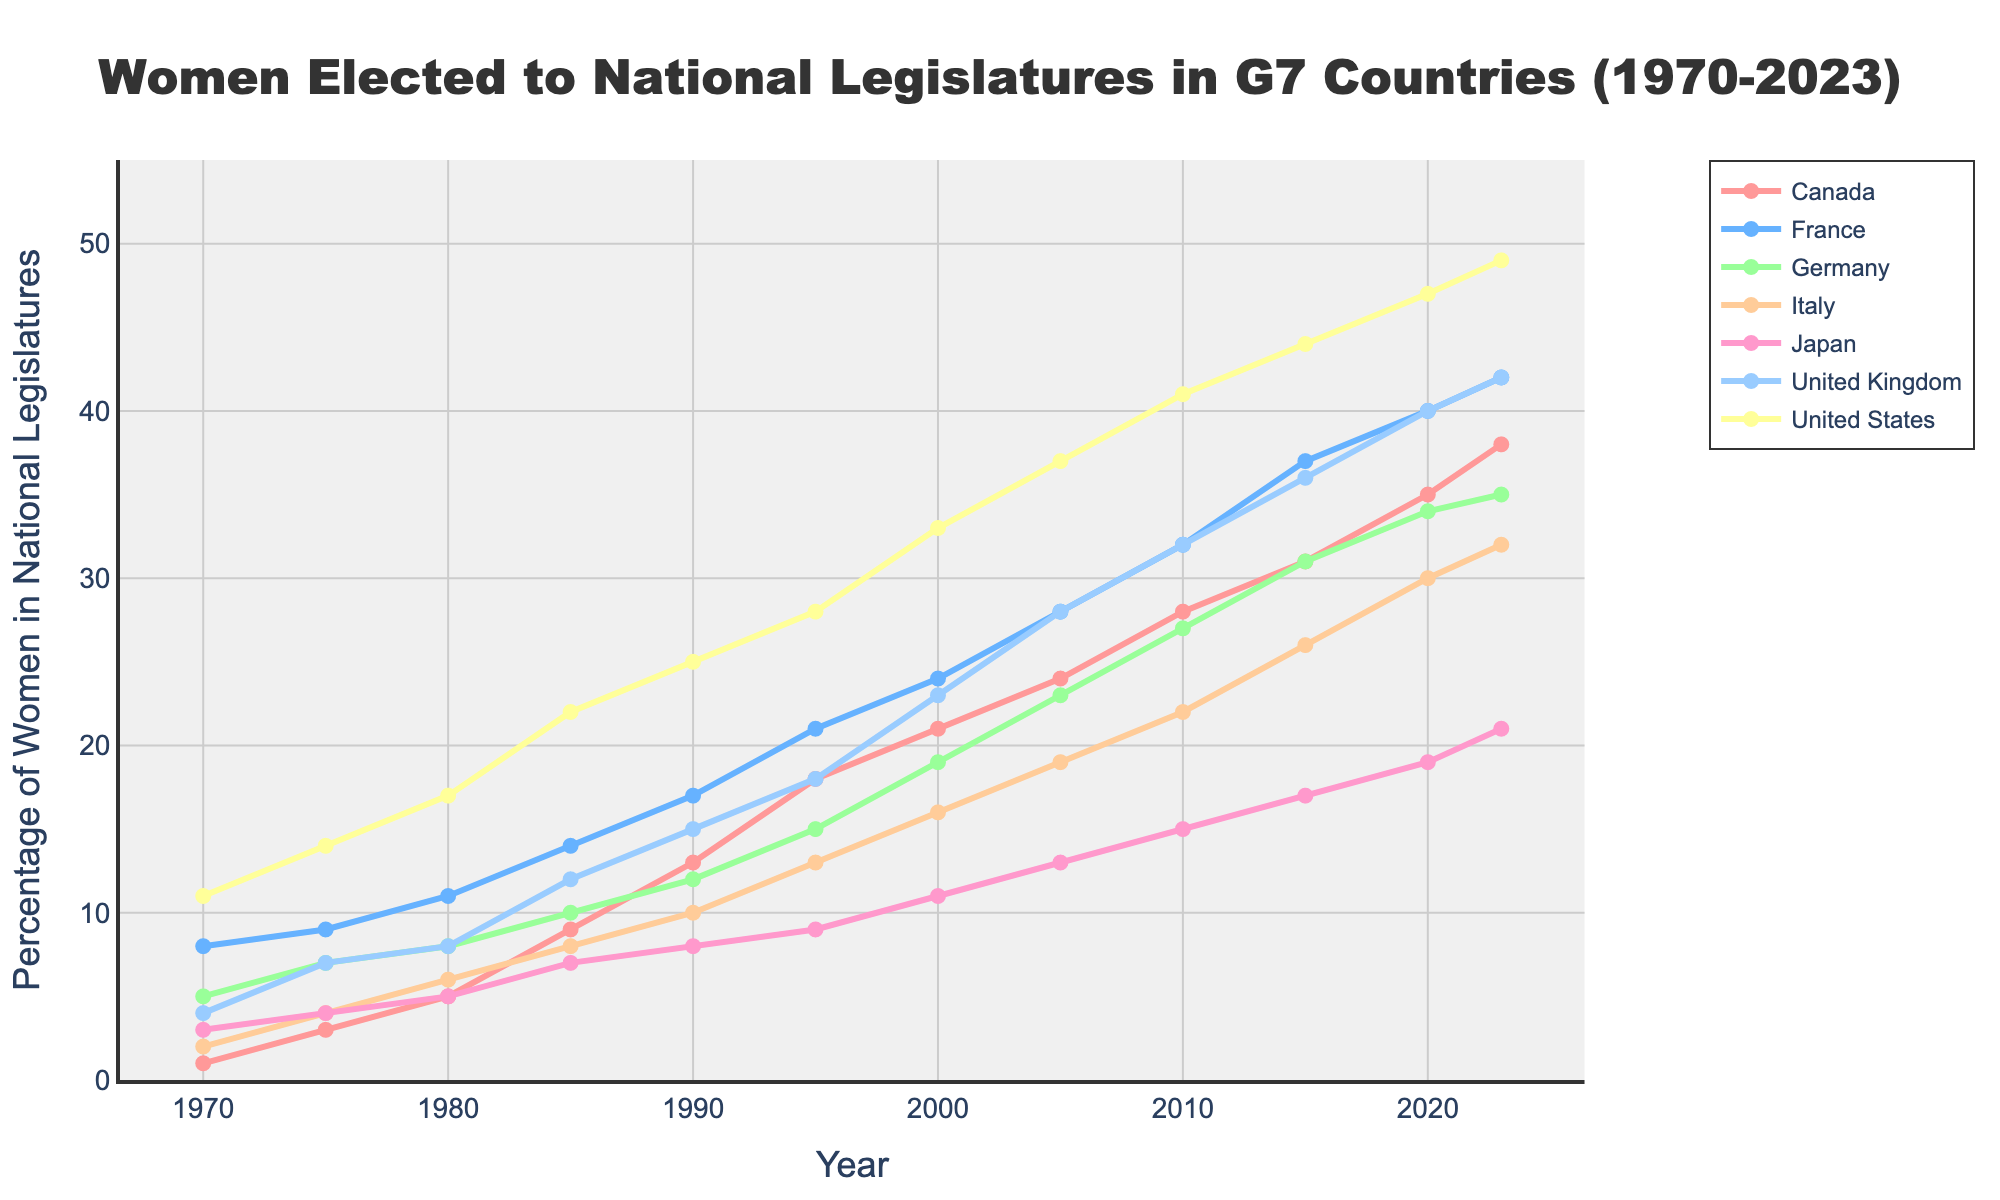What year did Canada reach a number of 20 women elected to national legislatures? By observing the figure, notice that Canada reached above 20 women between 1995 and 2000. Checking the exact line, the year is around 2000.
Answer: 2000 Which country had the highest number of women elected in the latest year, and what is that number? At the end of the plot (2023), the United States has the highest line, indicating it had the most women elected. The count is 49.
Answer: United States, 49 Between 1985 and 1995, which country showed the highest increase in the number of women elected? Comparing the slopes from 1985 to 1995, France had the steepest rise, from 14 to 21, indicating the highest increase.
Answer: France What is the average number of women elected in Germany over the entire period shown? Sum the women elected in Germany for each year (5+7+8+10+12+15+19+23+27+31+34+35 = 226) and divide by the number of years (12): 226/12 ≈ 18.83.
Answer: 18.83 What is the difference between the number of women elected in Japan and Italy in 2023? Observe the counts for Japan (21) and Italy (32) in 2023 and subtract them: 32 - 21 = 11.
Answer: 11 Which country had the least number of women elected in 1985? Looking at the plot points for 1985, Italy had the lowest count with 8 women elected.
Answer: Italy Between 1970 and 2023, how many times did the United Kingdom surpass 30 women elected? By checking the plotted values, the UK first exceeds 30 in 2010 and continues in 2015, 2020, and 2023, for a total of 4 instances.
Answer: 4 What was the total number of women elected in France and the United Kingdom in 2000? Add the numbers for France (24) and the UK (23): 24 + 23 = 47.
Answer: 47 Which country had the most consistent (steady) growth in the number of women elected over the years? By visual inspection, Germany's line graph shows the most steady upward trend without significant fluctuations.
Answer: Germany 